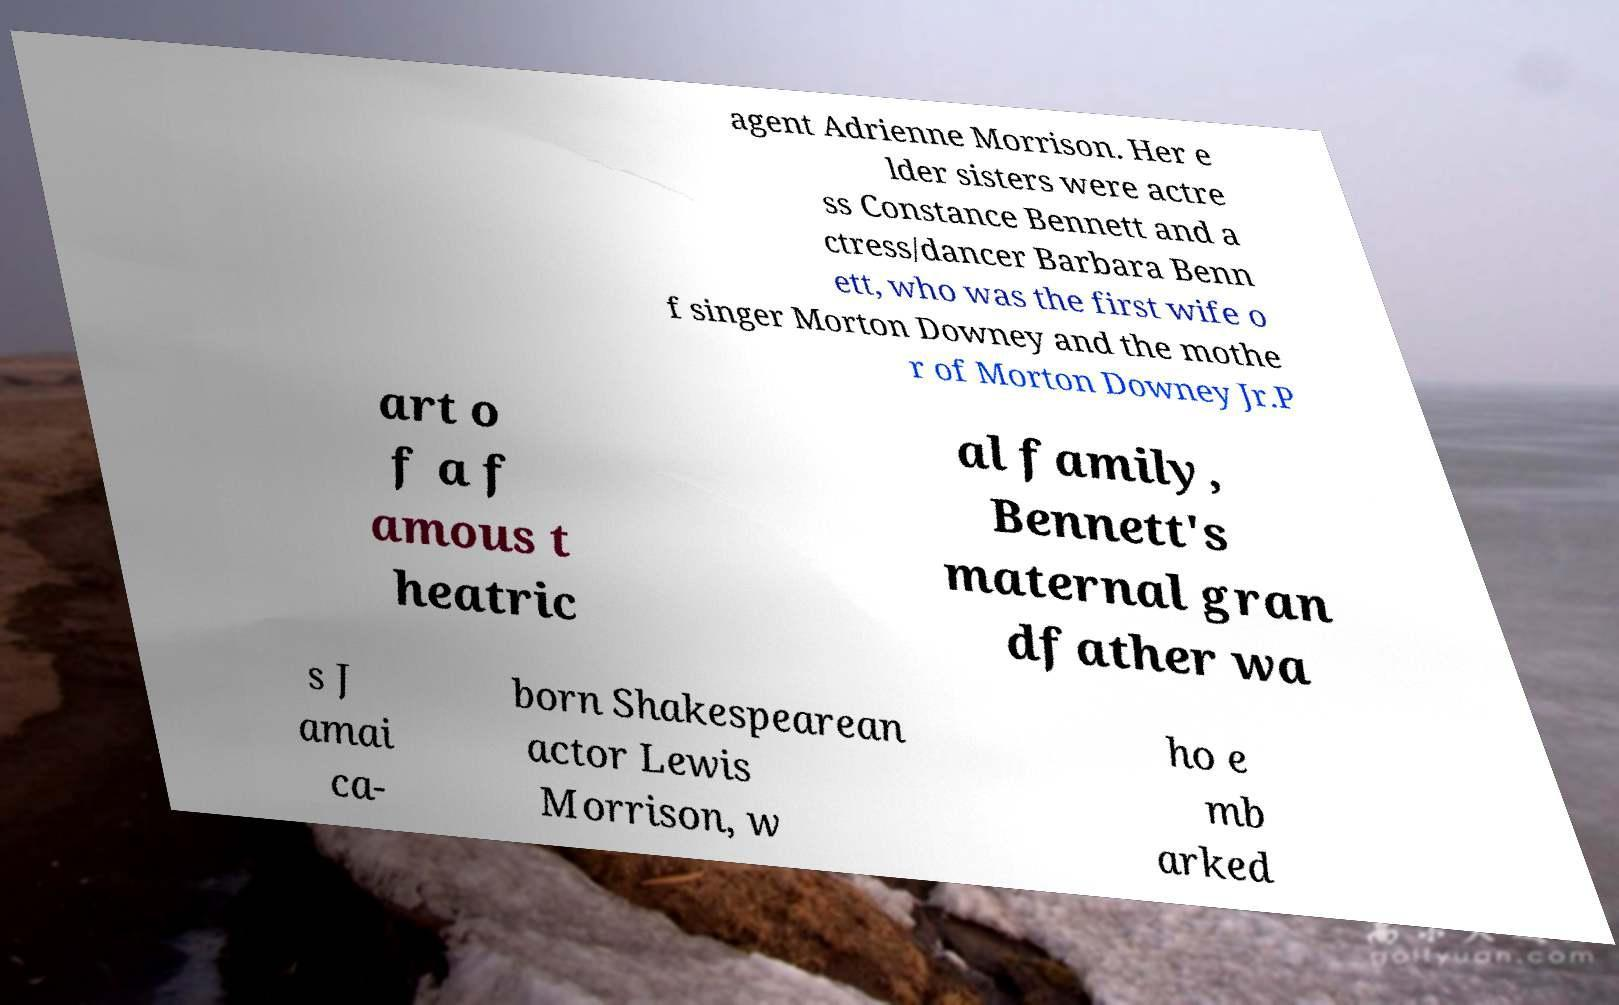For documentation purposes, I need the text within this image transcribed. Could you provide that? agent Adrienne Morrison. Her e lder sisters were actre ss Constance Bennett and a ctress/dancer Barbara Benn ett, who was the first wife o f singer Morton Downey and the mothe r of Morton Downey Jr.P art o f a f amous t heatric al family, Bennett's maternal gran dfather wa s J amai ca- born Shakespearean actor Lewis Morrison, w ho e mb arked 